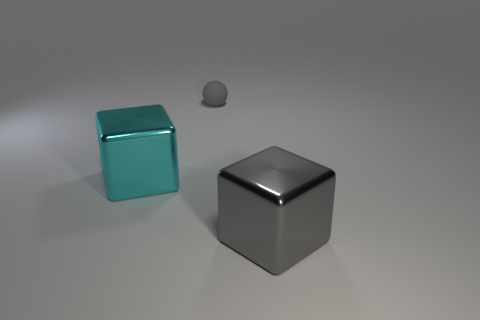Are there any other things that have the same material as the ball?
Make the answer very short. No. There is a block in front of the large shiny thing behind the metallic object in front of the cyan object; what size is it?
Your answer should be compact. Large. Is the size of the sphere the same as the cyan cube?
Your answer should be very brief. No. What number of things are either metallic objects or small blue things?
Make the answer very short. 2. There is a metal block that is right of the gray thing that is behind the large cyan cube; what is its size?
Your answer should be compact. Large. What is the size of the gray matte ball?
Your answer should be compact. Small. There is a object that is both to the left of the big gray object and in front of the matte object; what is its shape?
Give a very brief answer. Cube. The other large thing that is the same shape as the cyan metal object is what color?
Keep it short and to the point. Gray. What number of things are either objects left of the gray metallic object or objects that are on the right side of the cyan cube?
Your answer should be very brief. 3. The large gray metallic thing has what shape?
Your response must be concise. Cube. 